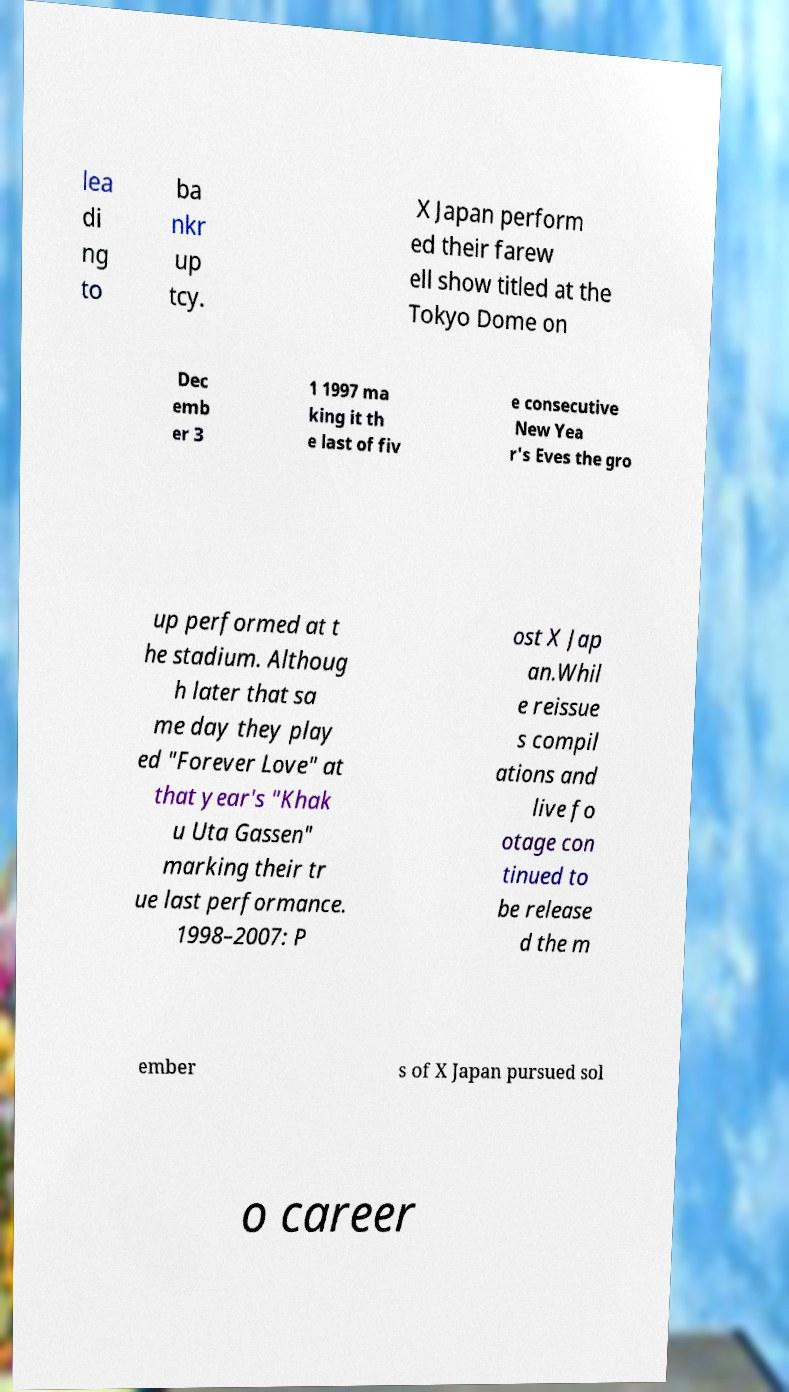Please identify and transcribe the text found in this image. lea di ng to ba nkr up tcy. X Japan perform ed their farew ell show titled at the Tokyo Dome on Dec emb er 3 1 1997 ma king it th e last of fiv e consecutive New Yea r's Eves the gro up performed at t he stadium. Althoug h later that sa me day they play ed "Forever Love" at that year's "Khak u Uta Gassen" marking their tr ue last performance. 1998–2007: P ost X Jap an.Whil e reissue s compil ations and live fo otage con tinued to be release d the m ember s of X Japan pursued sol o career 